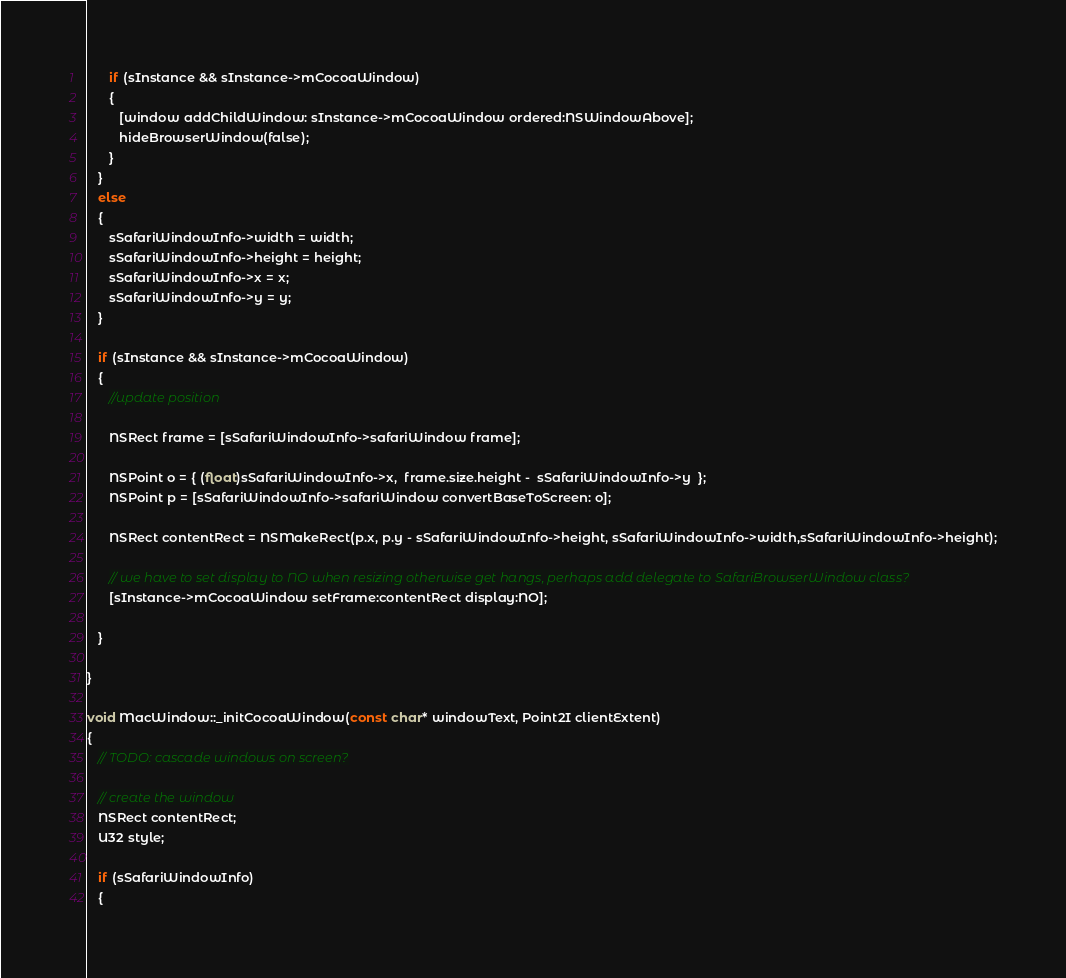Convert code to text. <code><loc_0><loc_0><loc_500><loc_500><_ObjectiveC_>      if (sInstance && sInstance->mCocoaWindow)
      {
         [window addChildWindow: sInstance->mCocoaWindow ordered:NSWindowAbove];
         hideBrowserWindow(false);
      }
   }
   else
   {
      sSafariWindowInfo->width = width;
      sSafariWindowInfo->height = height;
      sSafariWindowInfo->x = x;
      sSafariWindowInfo->y = y;   
   }
   
   if (sInstance && sInstance->mCocoaWindow)
   {
      //update position
      
      NSRect frame = [sSafariWindowInfo->safariWindow frame];
      
      NSPoint o = { (float)sSafariWindowInfo->x,  frame.size.height -  sSafariWindowInfo->y  };      
      NSPoint p = [sSafariWindowInfo->safariWindow convertBaseToScreen: o];
            
      NSRect contentRect = NSMakeRect(p.x, p.y - sSafariWindowInfo->height, sSafariWindowInfo->width,sSafariWindowInfo->height);
      
      // we have to set display to NO when resizing otherwise get hangs, perhaps add delegate to SafariBrowserWindow class?
      [sInstance->mCocoaWindow setFrame:contentRect display:NO];
            
   }
   
}
   
void MacWindow::_initCocoaWindow(const char* windowText, Point2I clientExtent)
{
   // TODO: cascade windows on screen?
   
   // create the window
   NSRect contentRect;
   U32 style;
   
   if (sSafariWindowInfo)
   {</code> 